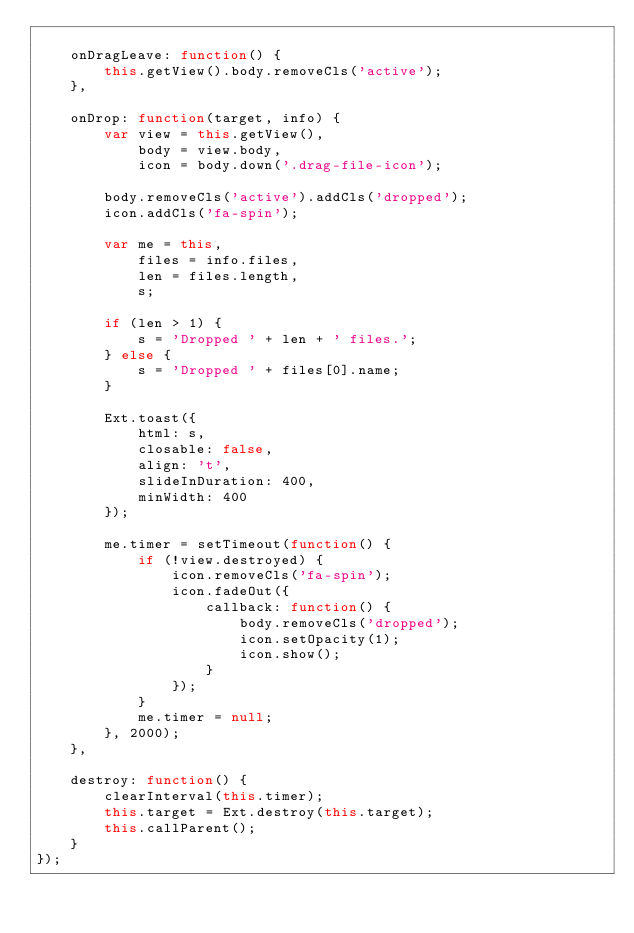Convert code to text. <code><loc_0><loc_0><loc_500><loc_500><_JavaScript_>
    onDragLeave: function() {
        this.getView().body.removeCls('active');
    },

    onDrop: function(target, info) {
        var view = this.getView(),
            body = view.body,
            icon = body.down('.drag-file-icon');

        body.removeCls('active').addCls('dropped');
        icon.addCls('fa-spin');

        var me = this,
            files = info.files,
            len = files.length,
            s;

        if (len > 1) {
            s = 'Dropped ' + len + ' files.';
        } else {
            s = 'Dropped ' + files[0].name;
        }

        Ext.toast({
            html: s,
            closable: false,
            align: 't',
            slideInDuration: 400,
            minWidth: 400
        });

        me.timer = setTimeout(function() {
            if (!view.destroyed) {
                icon.removeCls('fa-spin');
                icon.fadeOut({
                    callback: function() {
                        body.removeCls('dropped');
                        icon.setOpacity(1);
                        icon.show();
                    }
                });
            }
            me.timer = null;
        }, 2000);
    },

    destroy: function() {
        clearInterval(this.timer);
        this.target = Ext.destroy(this.target);
        this.callParent();
    }
});</code> 